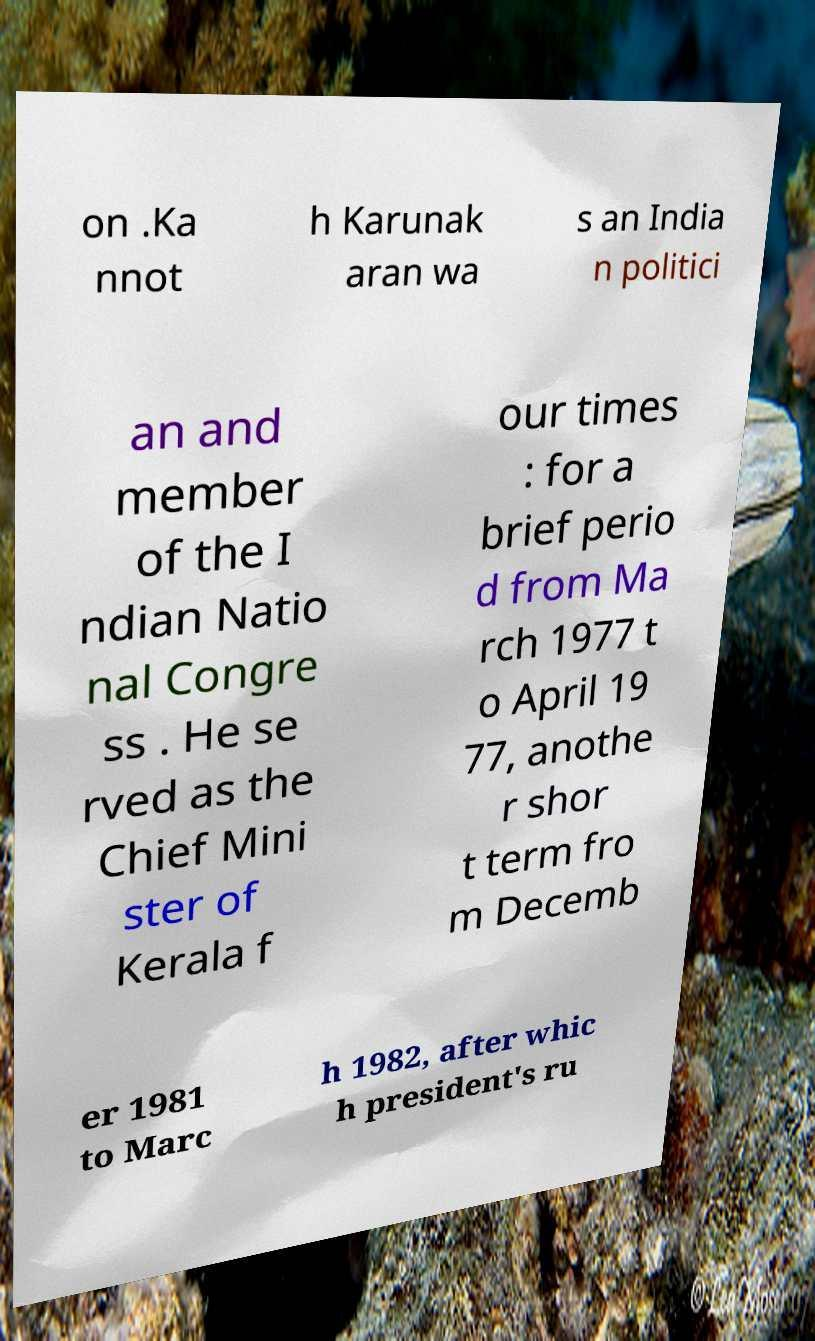What messages or text are displayed in this image? I need them in a readable, typed format. on .Ka nnot h Karunak aran wa s an India n politici an and member of the I ndian Natio nal Congre ss . He se rved as the Chief Mini ster of Kerala f our times : for a brief perio d from Ma rch 1977 t o April 19 77, anothe r shor t term fro m Decemb er 1981 to Marc h 1982, after whic h president's ru 